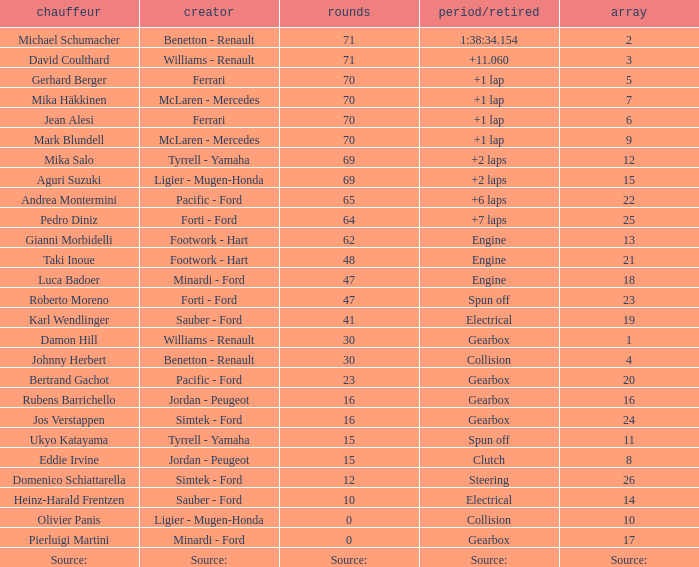How many laps were there in grid 21? 48.0. 